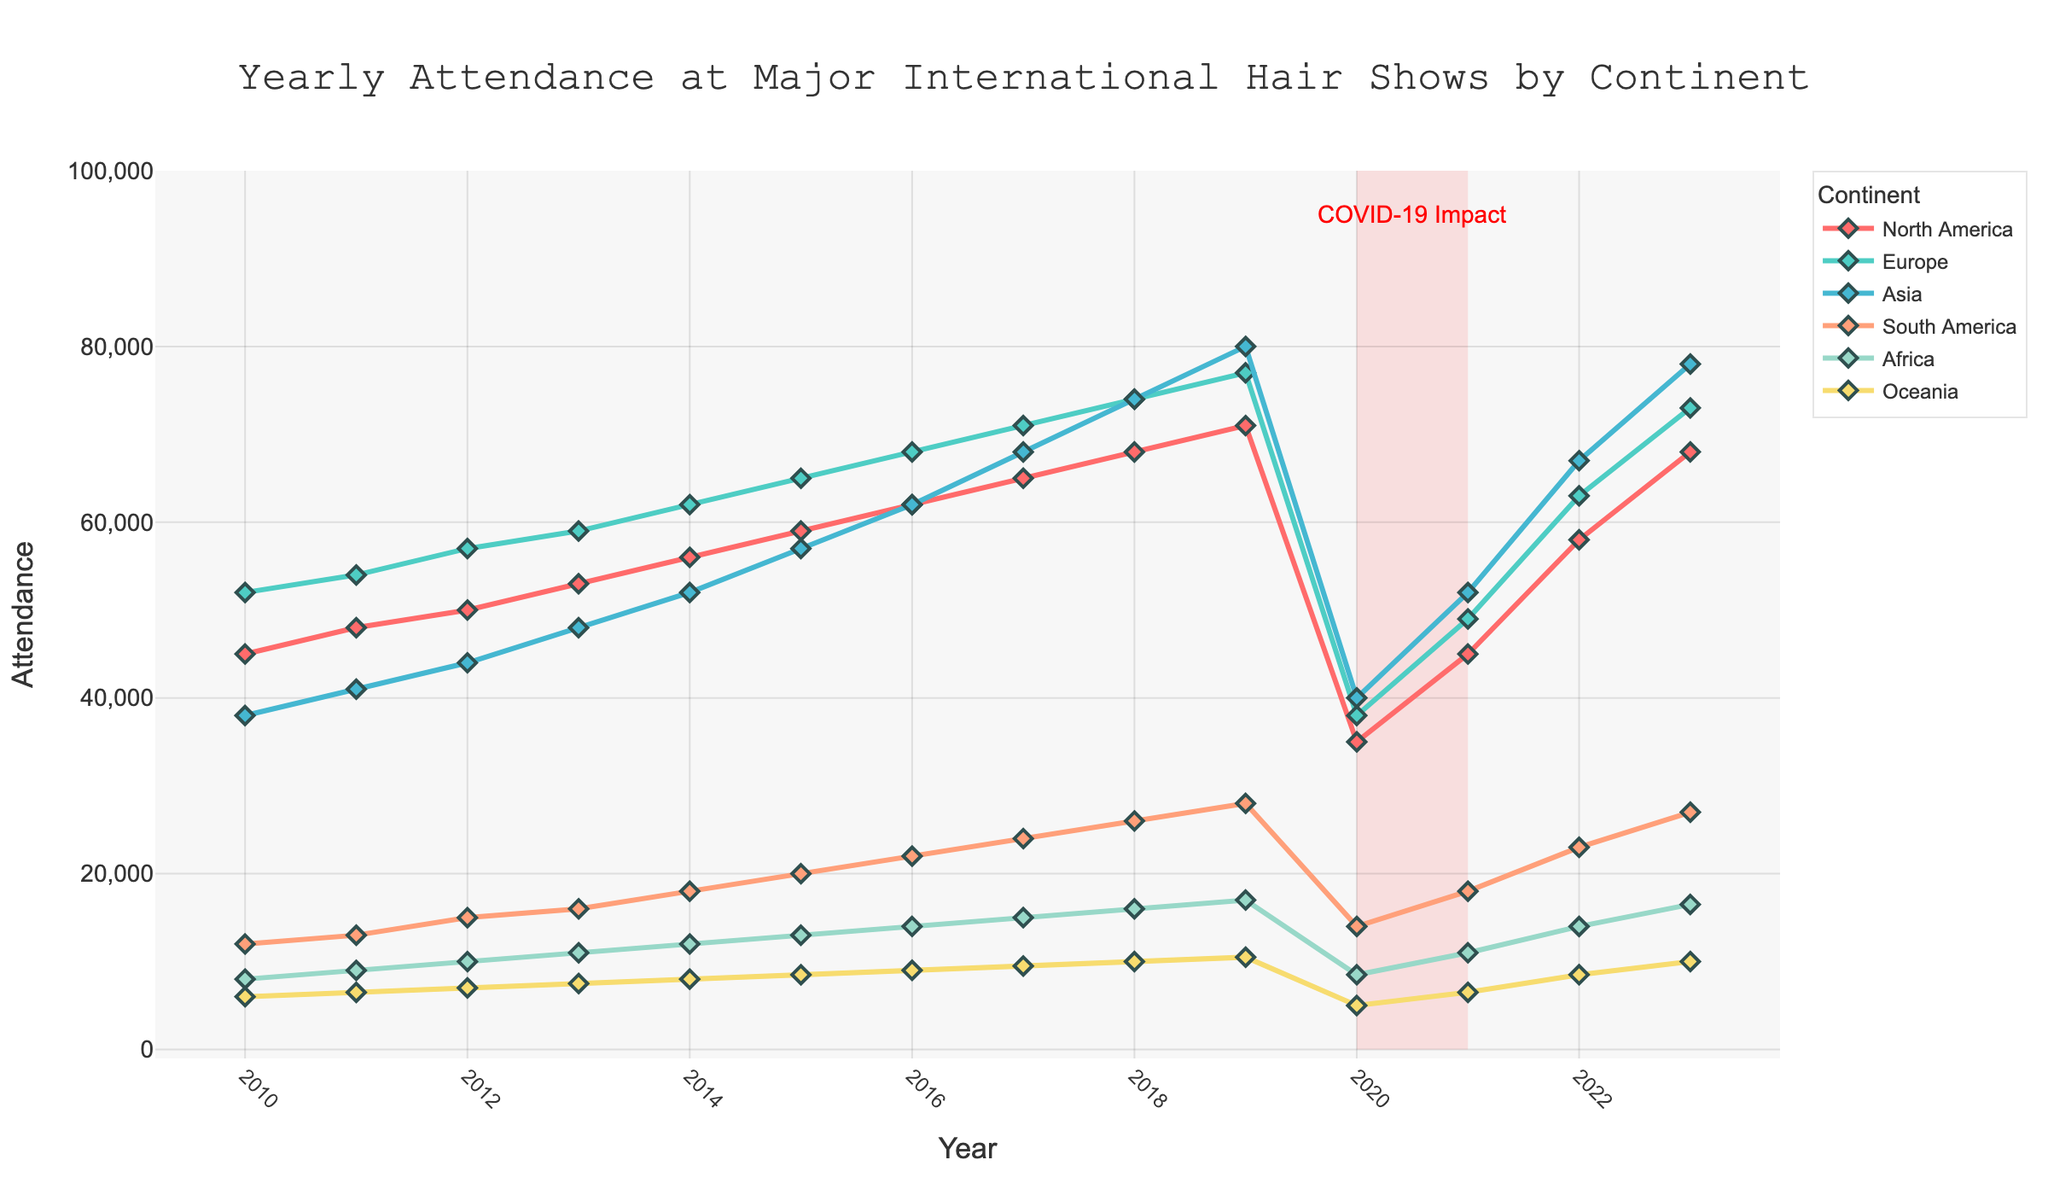What is the overall trend in attendance figures for North America from 2010 to 2023? The attendance for North America shows a general increasing trend from 45,000 in 2010 to 68,000 in 2023, with a significant drop to 35,000 in 2020 due to the COVID-19 pandemic period and then a recovery in subsequent years.
Answer: Increasing trend Which continent had the highest attendance in 2019? In 2019, the attendance figures were North America: 71,000, Europe: 77,000, Asia: 80,000, South America: 28,000, Africa: 17,000, Oceania: 10,500. Asia had the highest attendance.
Answer: Asia How did the attendance figures for Europe change from 2010 to 2020? Europe's attendance increased steadily from 52,000 in 2010 to 77,000 in 2019, and then dropped to 38,000 in 2020, showing a rise followed by a significant drop due to the COVID-19 impact.
Answer: Increased then dropped Which continent showed the most consistent growth in attendance over the years 2010 to 2019? Asia showed the most consistent growth, starting at 38,000 in 2010 and rising steadily to 80,000 in 2019 without any dips or plateaus in between.
Answer: Asia By how much did the attendance in South America increase from 2010 to 2019? The attendance in South America rose from 12,000 in 2010 to 28,000 in 2019. The increase is 28,000 - 12,000 = 16,000.
Answer: 16,000 Compare the attendance figures for North America and Asia in 2016. Which one had higher attendance and by how much? In 2016, North America had 62,000 attendees and Asia had 62,000 attendees. Since both values are equal, there is no difference in attendance.
Answer: Equal, 0 Which year had the lowest attendance for Oceania, and what was the figure? The year with the lowest attendance for Oceania was 2020, with an attendance figure of 5,000.
Answer: 2020, 5,000 What is the total attendance across all continents for the year 2018? The sum of attendances for all continents in 2018 is North America: 68,000 + Europe: 74,000 + Asia: 74,000 + South America: 26,000 + Africa: 16,000 + Oceania: 10,000. Total attendance = 68,000 + 74,000 + 74,000 + 26,000 + 16,000 + 10,000 = 268,000.
Answer: 268,000 How does the attendance in Africa change after the COVID-19 period compared to before? Before COVID-19 (2010-2019), Africa's attendance increased from 8,000 to 17,000. After COVID-19 (2022-2023), the attendance recovered to 14,000 in 2022 and increased to 16,500 in 2023. The attendance initially recovered and then continued to grow, though it hasn't yet returned to the peak levels seen in 2019.
Answer: Initial recovery, then growth 